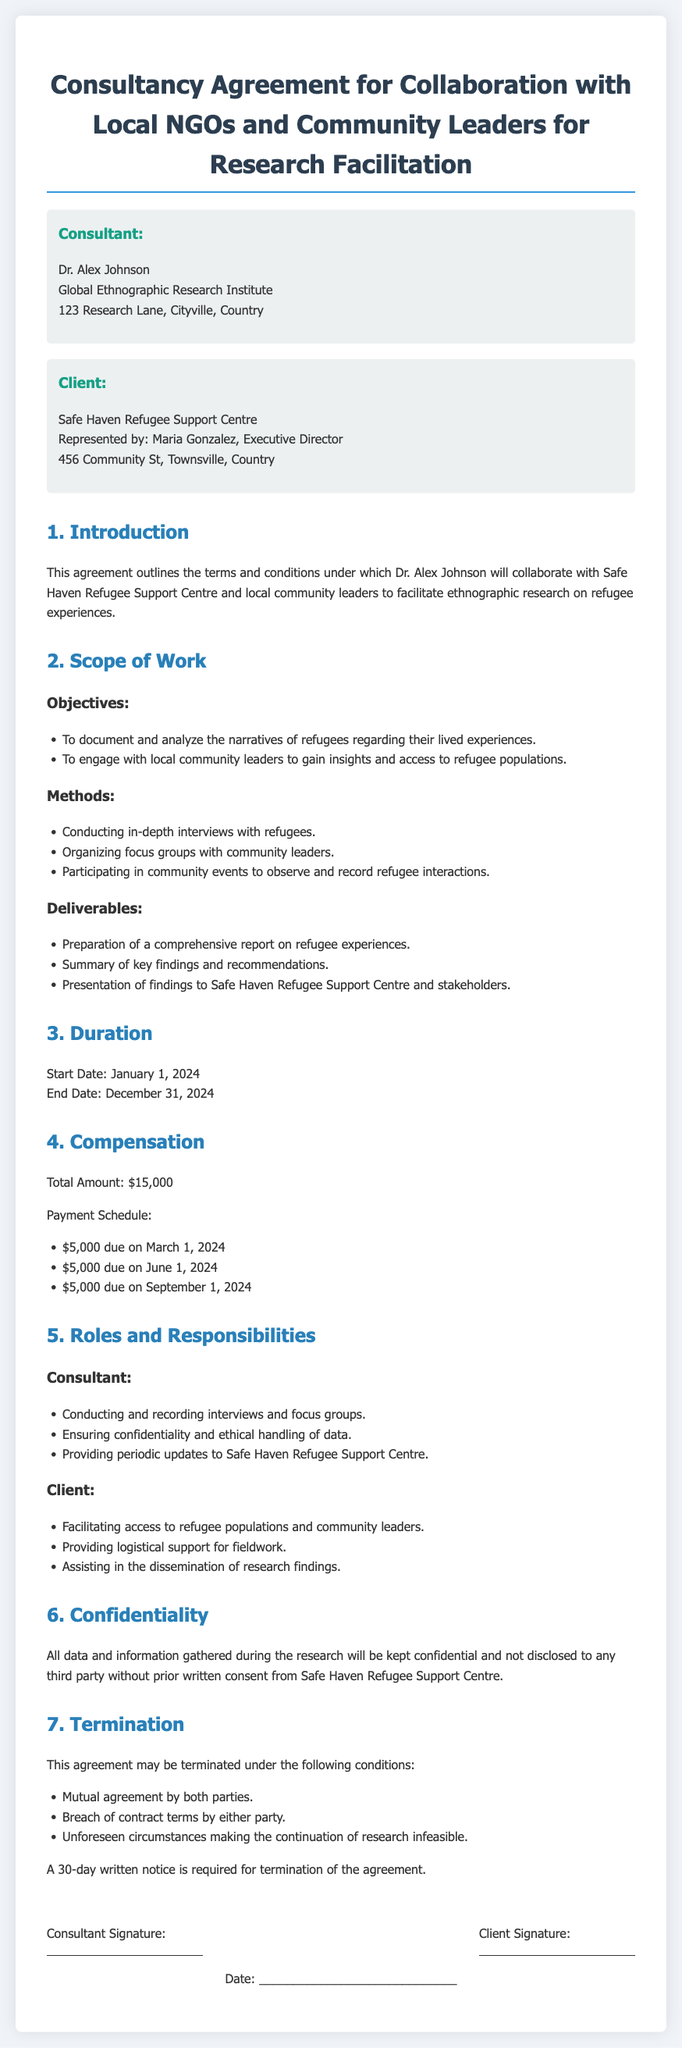What is the name of the consultant? The name of the consultant is mentioned in the document as Dr. Alex Johnson.
Answer: Dr. Alex Johnson What is the start date of the agreement? The start date is outlined in the Duration section of the document.
Answer: January 1, 2024 What is the total compensation amount? The total compensation amount is explicitly stated in the Compensation section of the document.
Answer: $15,000 Who represents the client organization? The Client section names Maria Gonzalez as the Executive Director representing Safe Haven Refugee Support Centre.
Answer: Maria Gonzalez What is one method used in the research? The methods section lists specific approaches for the research, one of which is conducting in-depth interviews.
Answer: Conducting in-depth interviews What are the conditions for terminating the agreement? The termination section outlines specific conditions under which the agreement can be terminated, including mutual agreement.
Answer: Mutual agreement How many payments are specified in the payment schedule? The payment schedule details the number of payments and their due dates outlined in the Compensation section.
Answer: 3 What is the main purpose of this agreement? The introduction section provides an overview of the overall purpose of this consultancy agreement.
Answer: To facilitate ethnographic research on refugee experiences What is required for termination of the agreement? The termination section specifies the requirement for notice prior to termination.
Answer: 30-day written notice 